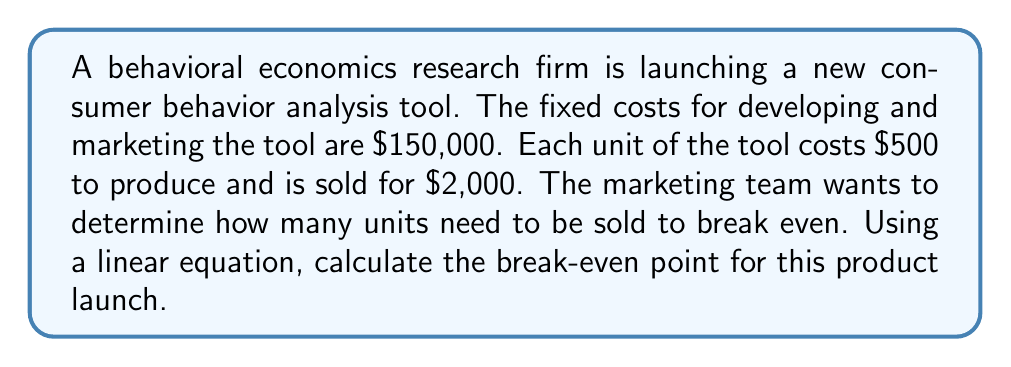Solve this math problem. To solve this problem, we'll use the break-even formula, which is a linear equation:

$$\text{Total Revenue} = \text{Total Costs}$$

Let's define our variables:
- $x$ = number of units sold
- Fixed costs = $150,000
- Variable cost per unit = $500
- Selling price per unit = $2,000

Now, let's set up our equation:

$$2000x = 150000 + 500x$$

This equation represents:
$\text{(Selling price per unit)} \times \text{(Number of units)} = \text{Fixed costs} + \text{(Variable cost per unit)} \times \text{(Number of units)}$

To solve for $x$, we'll follow these steps:

1) Subtract $500x$ from both sides:
   $$2000x - 500x = 150000$$
   $$1500x = 150000$$

2) Divide both sides by 1500:
   $$x = \frac{150000}{1500} = 100$$

Therefore, the break-even point is 100 units.

To verify:
- Total Revenue: $2000 \times 100 = $200,000
- Total Costs: $150000 + (500 \times 100) = $200,000

As Total Revenue equals Total Costs at 100 units, this confirms our break-even point.
Answer: The break-even point for the new consumer behavior analysis tool is 100 units. 